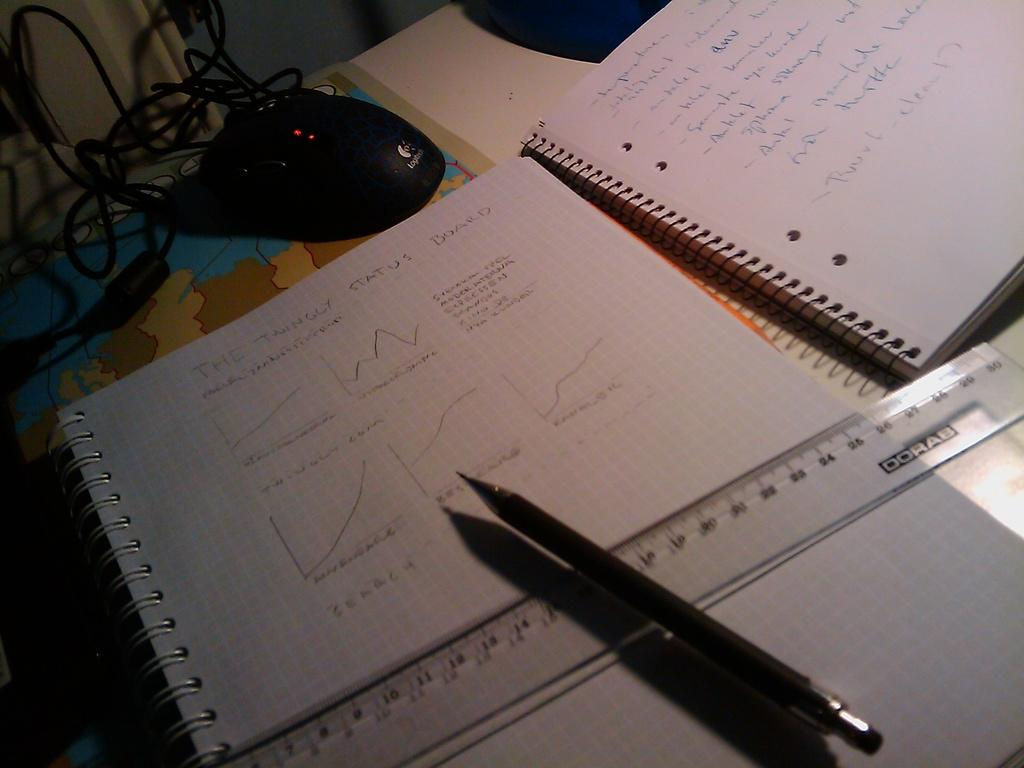<image>
Present a compact description of the photo's key features. A grid paper notebook with the words The Twingly Status written out 